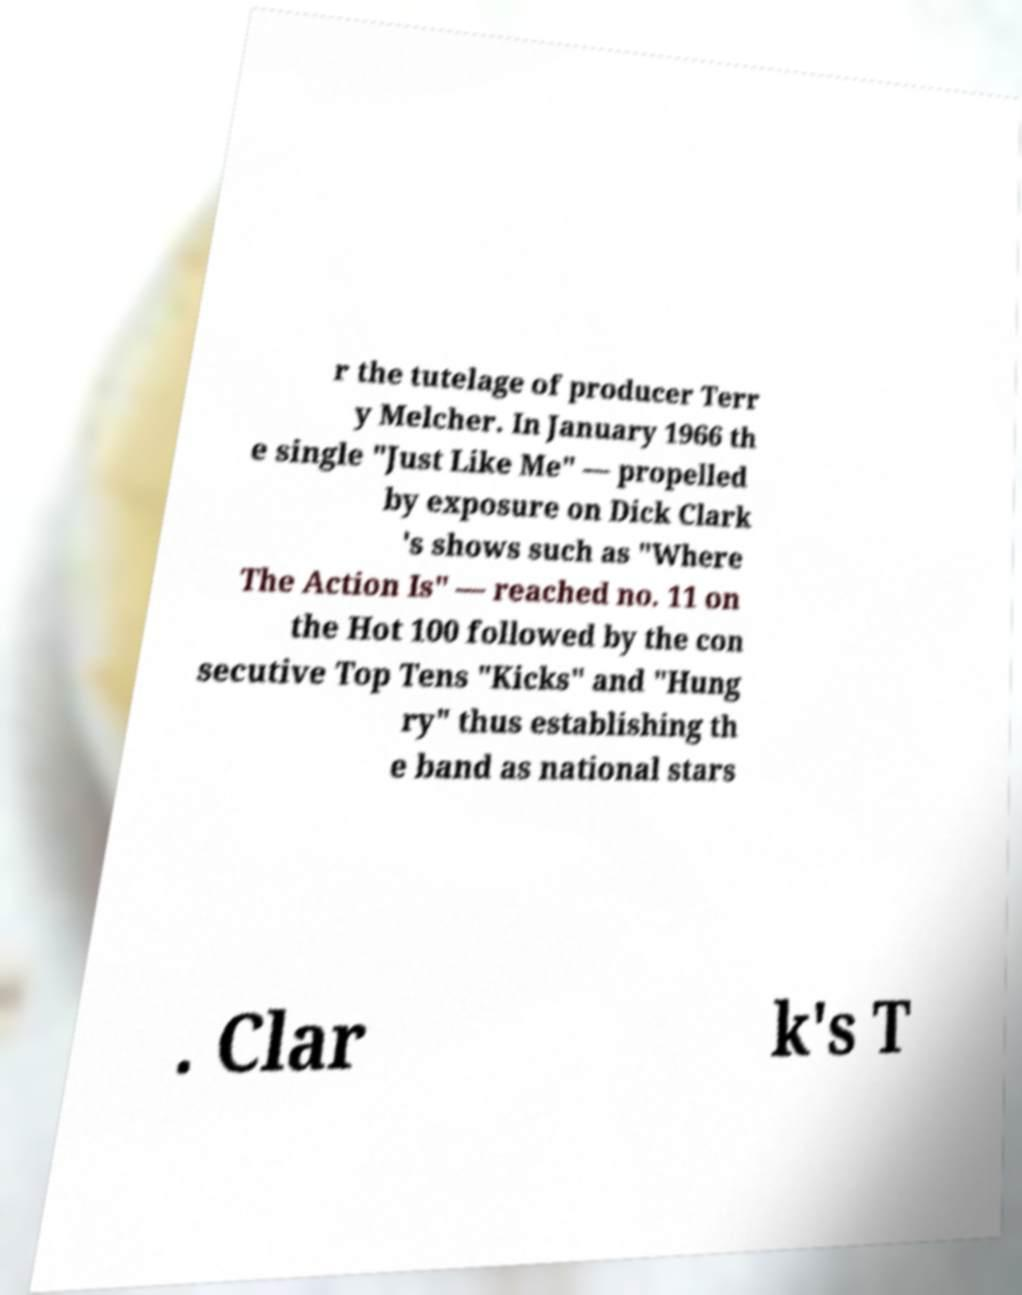Could you assist in decoding the text presented in this image and type it out clearly? r the tutelage of producer Terr y Melcher. In January 1966 th e single "Just Like Me" — propelled by exposure on Dick Clark 's shows such as "Where The Action Is" — reached no. 11 on the Hot 100 followed by the con secutive Top Tens "Kicks" and "Hung ry" thus establishing th e band as national stars . Clar k's T 